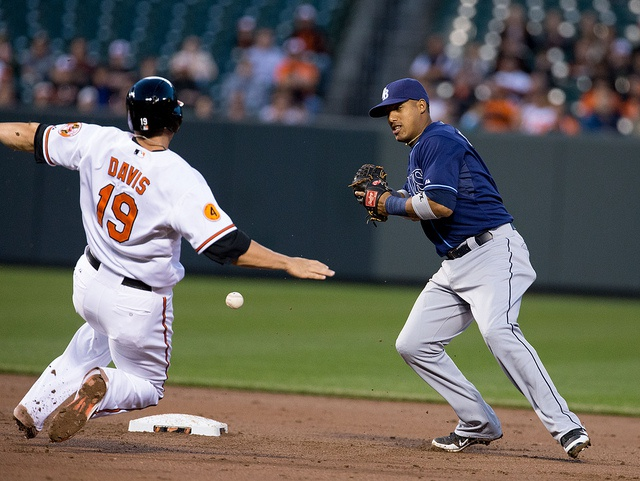Describe the objects in this image and their specific colors. I can see people in darkblue, lavender, black, and darkgray tones, people in darkblue, lavender, navy, black, and darkgray tones, people in darkblue, gray, and darkgray tones, people in darkblue, gray, and black tones, and people in darkblue, maroon, and brown tones in this image. 